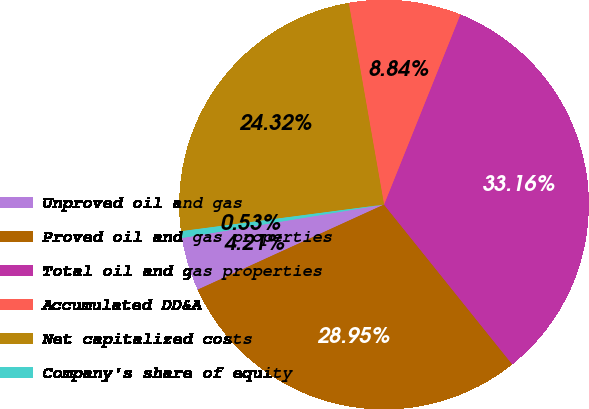<chart> <loc_0><loc_0><loc_500><loc_500><pie_chart><fcel>Unproved oil and gas<fcel>Proved oil and gas properties<fcel>Total oil and gas properties<fcel>Accumulated DD&A<fcel>Net capitalized costs<fcel>Company's share of equity<nl><fcel>4.21%<fcel>28.95%<fcel>33.16%<fcel>8.84%<fcel>24.32%<fcel>0.53%<nl></chart> 